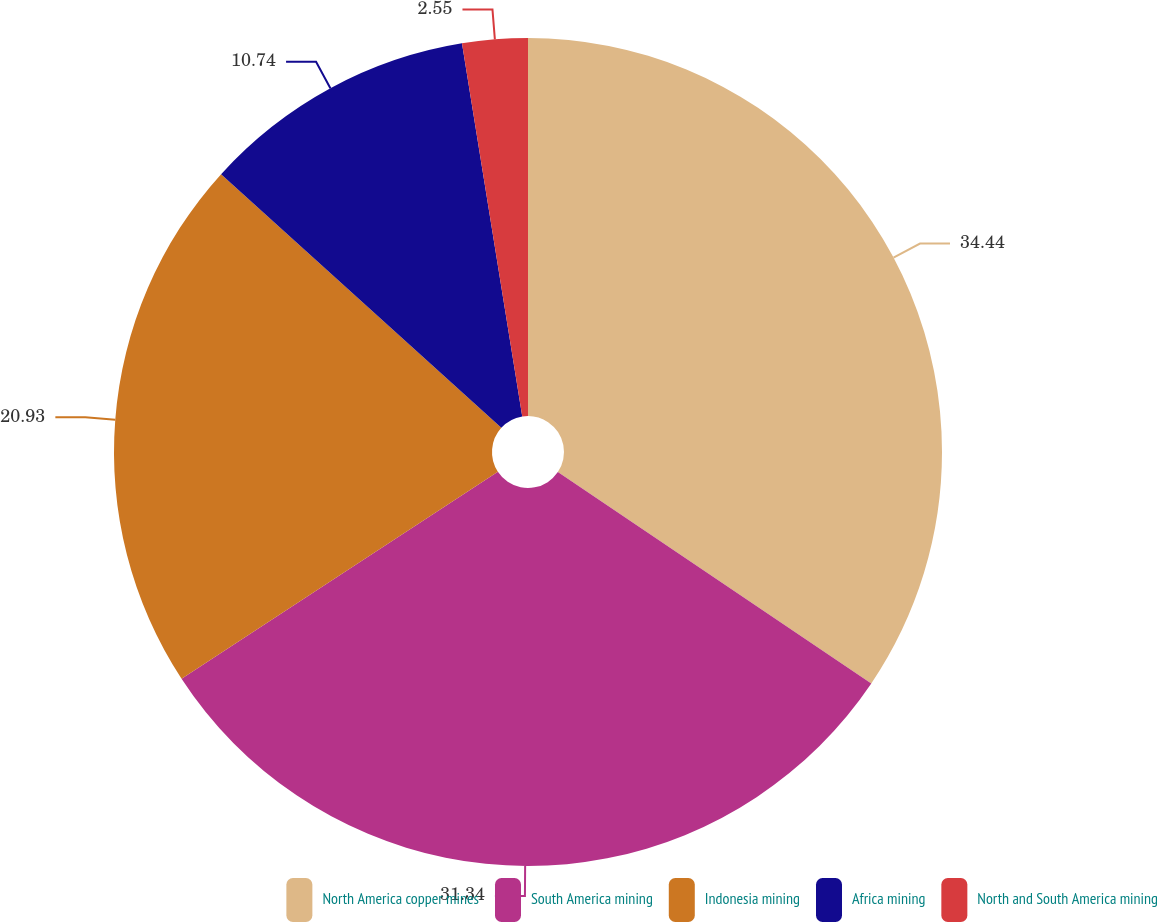<chart> <loc_0><loc_0><loc_500><loc_500><pie_chart><fcel>North America copper mines<fcel>South America mining<fcel>Indonesia mining<fcel>Africa mining<fcel>North and South America mining<nl><fcel>34.44%<fcel>31.34%<fcel>20.93%<fcel>10.74%<fcel>2.55%<nl></chart> 